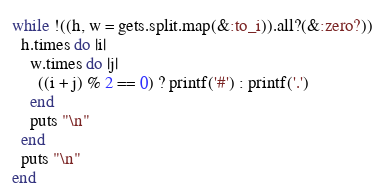<code> <loc_0><loc_0><loc_500><loc_500><_Ruby_>while !((h, w = gets.split.map(&:to_i)).all?(&:zero?))
  h.times do |i|
    w.times do |j|
      ((i + j) % 2 == 0) ? printf('#') : printf('.')
    end
    puts "\n"
  end
  puts "\n"
end
</code> 